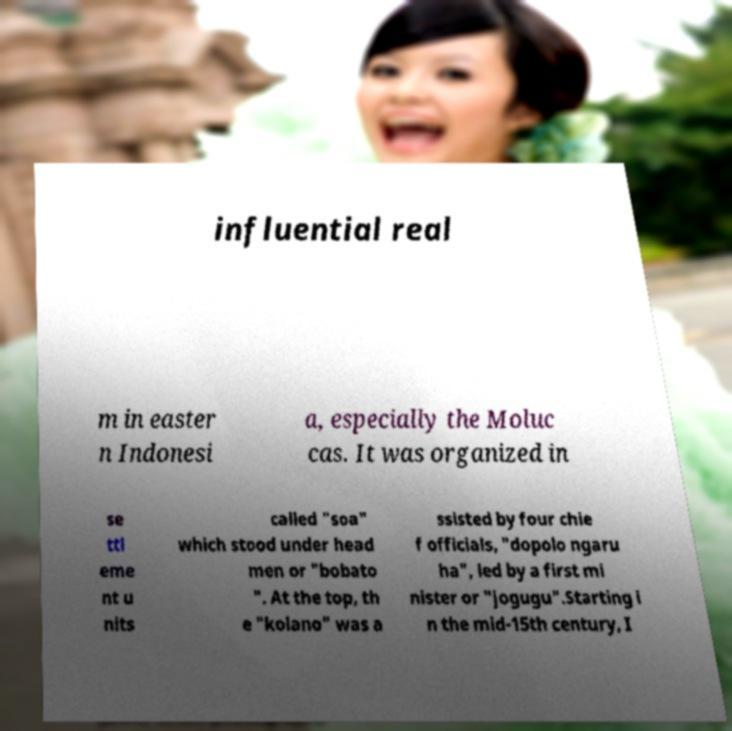I need the written content from this picture converted into text. Can you do that? influential real m in easter n Indonesi a, especially the Moluc cas. It was organized in se ttl eme nt u nits called "soa" which stood under head men or "bobato ". At the top, th e "kolano" was a ssisted by four chie f officials, "dopolo ngaru ha", led by a first mi nister or "jogugu".Starting i n the mid-15th century, I 